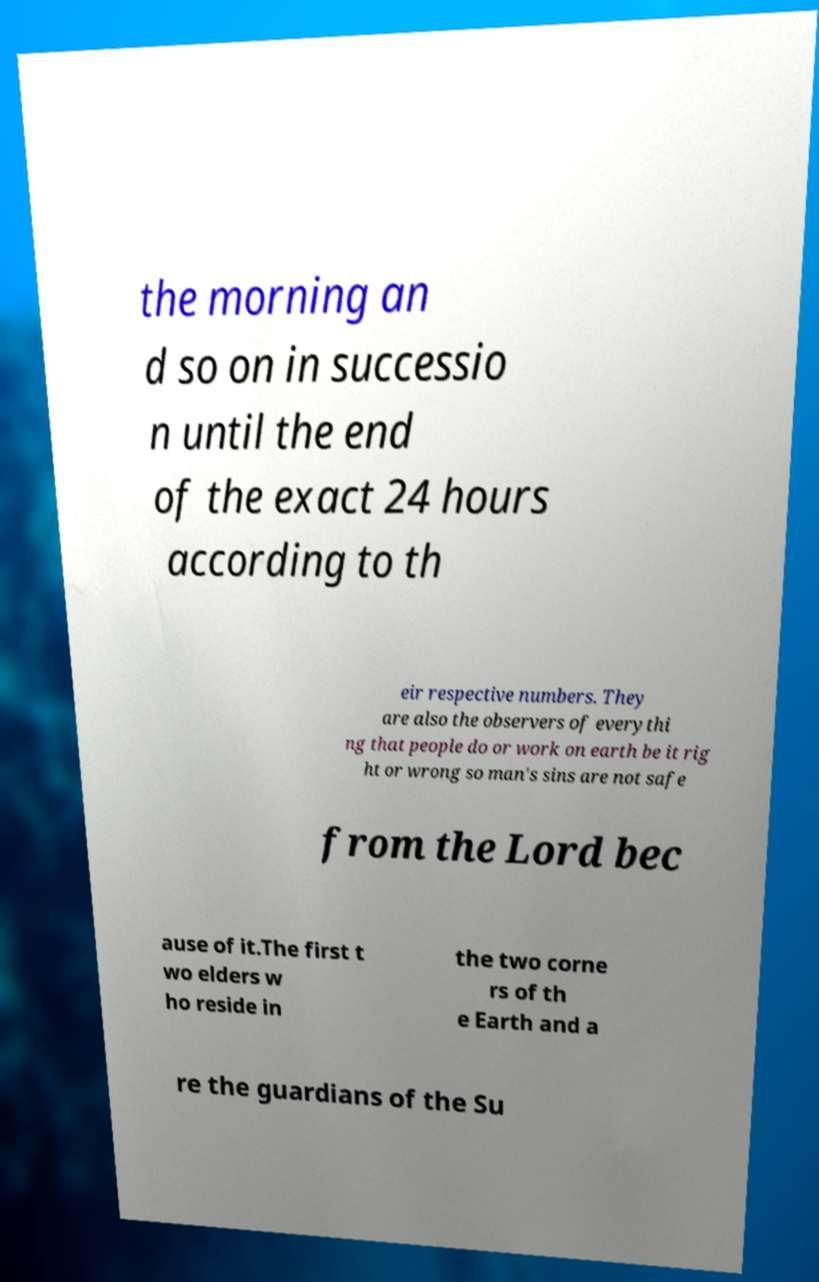Could you extract and type out the text from this image? the morning an d so on in successio n until the end of the exact 24 hours according to th eir respective numbers. They are also the observers of everythi ng that people do or work on earth be it rig ht or wrong so man's sins are not safe from the Lord bec ause of it.The first t wo elders w ho reside in the two corne rs of th e Earth and a re the guardians of the Su 